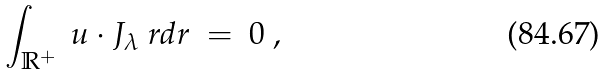<formula> <loc_0><loc_0><loc_500><loc_500>\int _ { \mathbb { R } ^ { + } } \ u \cdot J _ { \lambda } \ r d r \ = \ 0 \ ,</formula> 